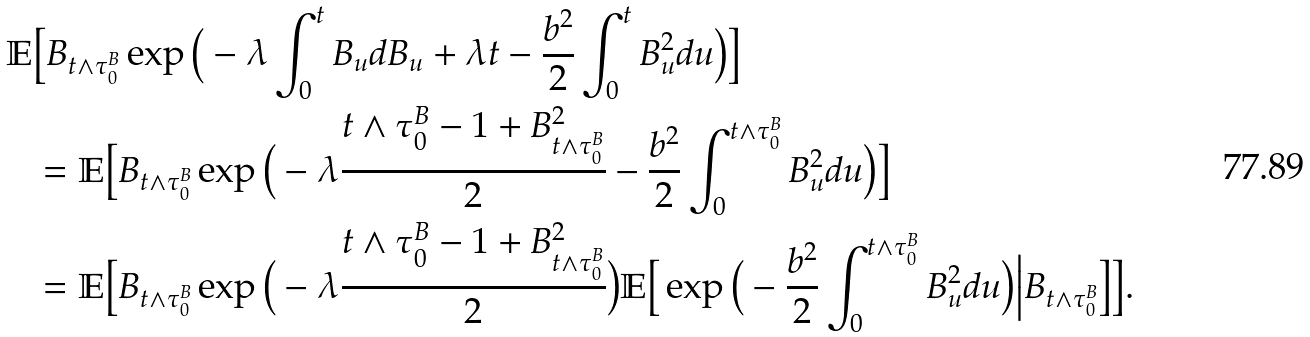<formula> <loc_0><loc_0><loc_500><loc_500>\mathbb { E } & \Big [ B _ { t \wedge \tau ^ { B } _ { 0 } } \exp \Big ( - \lambda \int _ { 0 } ^ { t } B _ { u } d B _ { u } + \lambda t - \frac { b ^ { 2 } } { 2 } \int _ { 0 } ^ { t } B _ { u } ^ { 2 } d u \Big ) \Big ] \\ & = \mathbb { E } \Big [ B _ { t \wedge \tau ^ { B } _ { 0 } } \exp \Big ( - \lambda \frac { t \wedge \tau ^ { B } _ { 0 } - 1 + B ^ { 2 } _ { t \wedge \tau ^ { B } _ { 0 } } } { 2 } - \frac { b ^ { 2 } } { 2 } \int _ { 0 } ^ { t \wedge \tau ^ { B } _ { 0 } } B _ { u } ^ { 2 } d u \Big ) \Big ] \\ & = \mathbb { E } \Big [ B _ { t \wedge \tau ^ { B } _ { 0 } } \exp \Big ( - \lambda \frac { t \wedge \tau ^ { B } _ { 0 } - 1 + B ^ { 2 } _ { t \wedge \tau ^ { B } _ { 0 } } } { 2 } \Big ) \mathbb { E } \Big [ \exp \Big ( - \frac { b ^ { 2 } } { 2 } \int _ { 0 } ^ { t \wedge \tau ^ { B } _ { 0 } } B _ { u } ^ { 2 } d u \Big ) \Big | B _ { t \wedge \tau ^ { B } _ { 0 } } \Big ] \Big ] .</formula> 